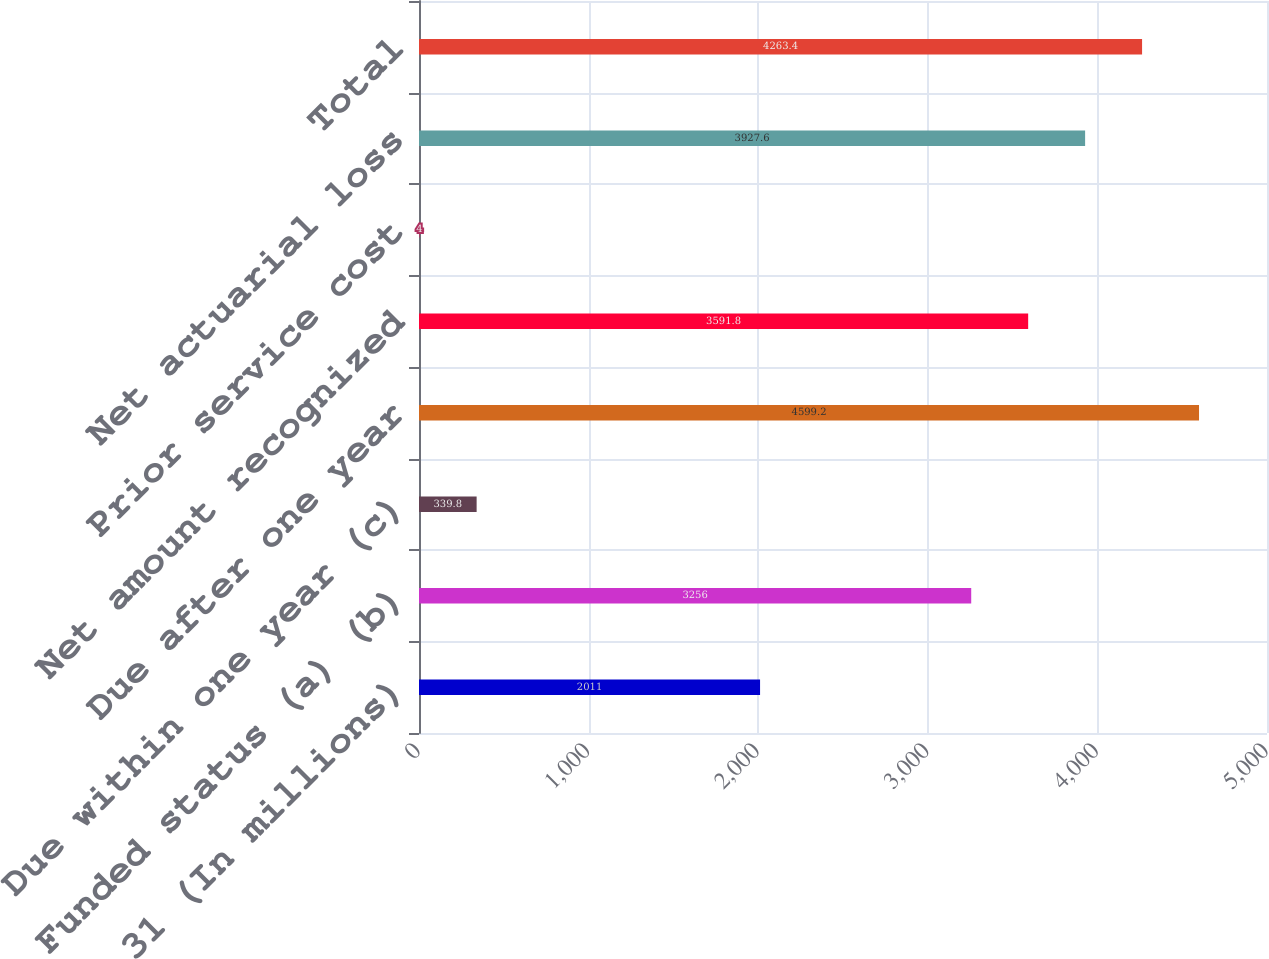<chart> <loc_0><loc_0><loc_500><loc_500><bar_chart><fcel>December 31 (In millions)<fcel>Funded status (a) (b)<fcel>Due within one year (c)<fcel>Due after one year<fcel>Net amount recognized<fcel>Prior service cost<fcel>Net actuarial loss<fcel>Total<nl><fcel>2011<fcel>3256<fcel>339.8<fcel>4599.2<fcel>3591.8<fcel>4<fcel>3927.6<fcel>4263.4<nl></chart> 